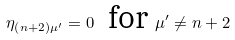<formula> <loc_0><loc_0><loc_500><loc_500>\eta _ { \left ( n + 2 \right ) \mu ^ { \prime } } = 0 \text { \ for } \mu ^ { \prime } \neq n + 2</formula> 